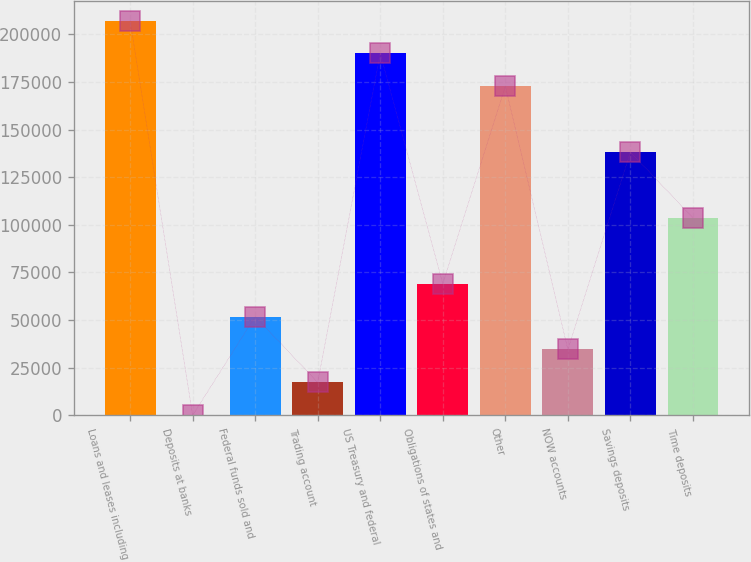Convert chart. <chart><loc_0><loc_0><loc_500><loc_500><bar_chart><fcel>Loans and leases including<fcel>Deposits at banks<fcel>Federal funds sold and<fcel>Trading account<fcel>US Treasury and federal<fcel>Obligations of states and<fcel>Other<fcel>NOW accounts<fcel>Savings deposits<fcel>Time deposits<nl><fcel>207303<fcel>15<fcel>51837<fcel>17289<fcel>190029<fcel>69111<fcel>172755<fcel>34563<fcel>138207<fcel>103659<nl></chart> 